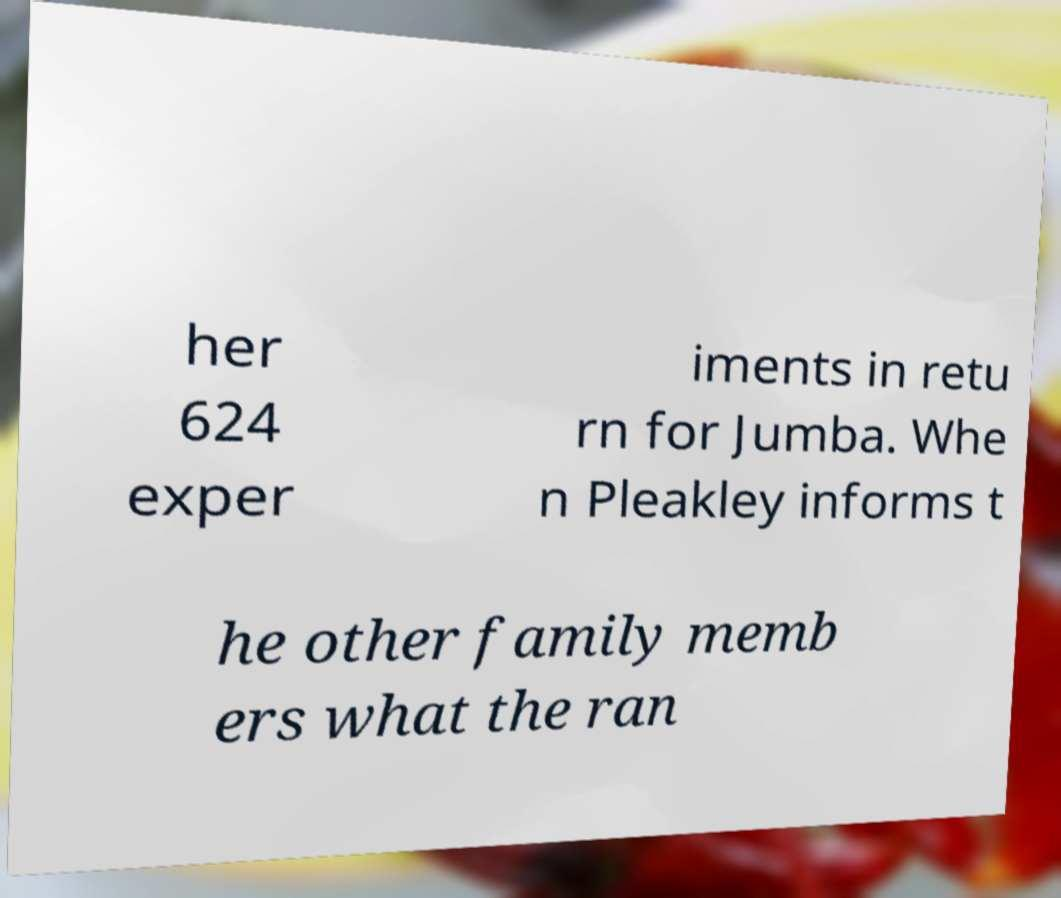For documentation purposes, I need the text within this image transcribed. Could you provide that? her 624 exper iments in retu rn for Jumba. Whe n Pleakley informs t he other family memb ers what the ran 